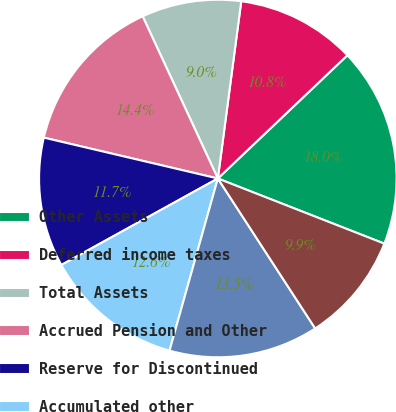Convert chart. <chart><loc_0><loc_0><loc_500><loc_500><pie_chart><fcel>Other Assets<fcel>Deferred income taxes<fcel>Total Assets<fcel>Accrued Pension and Other<fcel>Reserve for Discontinued<fcel>Accumulated other<fcel>Total Stockholders' equity<fcel>Total liabilities and<nl><fcel>18.04%<fcel>10.81%<fcel>9.0%<fcel>14.42%<fcel>11.71%<fcel>12.61%<fcel>13.52%<fcel>9.9%<nl></chart> 